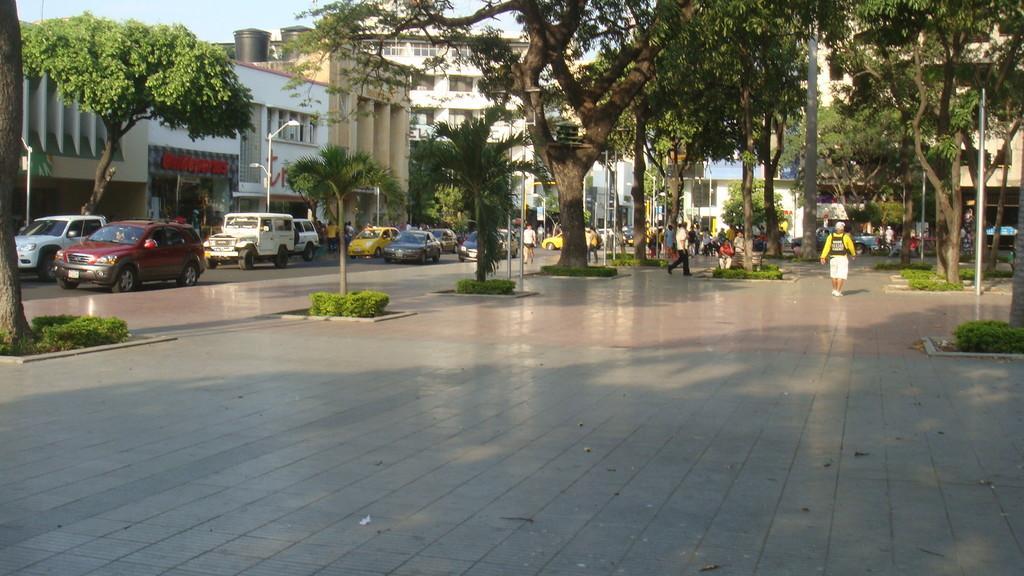Please provide a concise description of this image. There is pavement in the foreground area of the image, there are trees, poles, people, buildings and the sky in the background. 